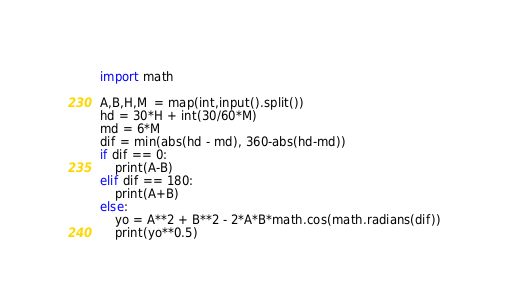<code> <loc_0><loc_0><loc_500><loc_500><_Python_>import math

A,B,H,M  = map(int,input().split())
hd = 30*H + int(30/60*M)
md = 6*M
dif = min(abs(hd - md), 360-abs(hd-md))
if dif == 0:
    print(A-B)
elif dif == 180:
    print(A+B)
else:
    yo = A**2 + B**2 - 2*A*B*math.cos(math.radians(dif))
    print(yo**0.5)
</code> 